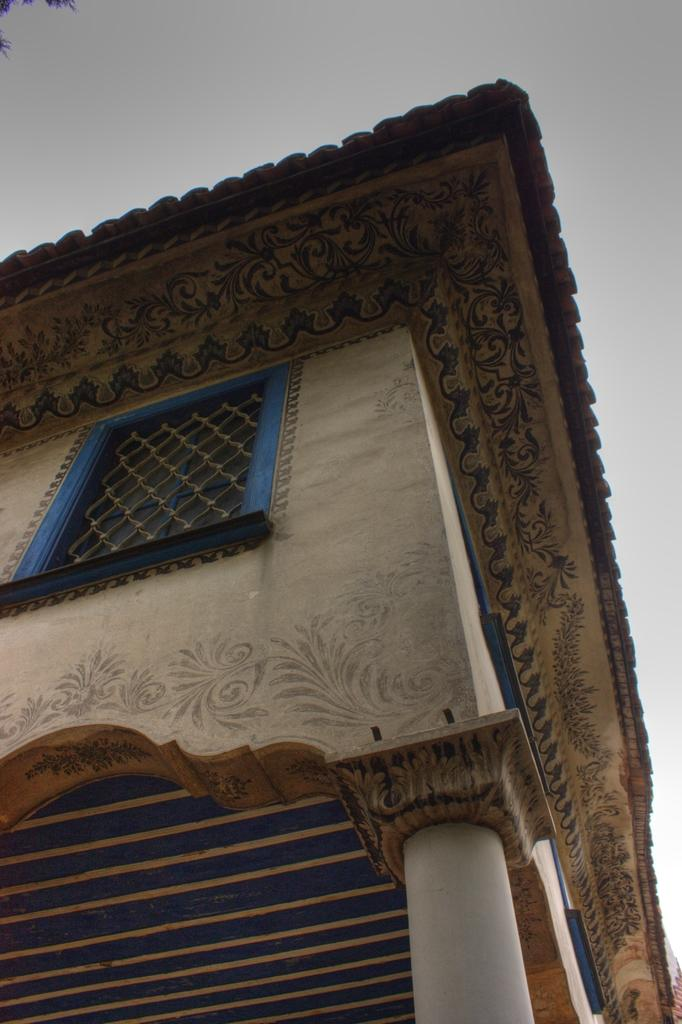Where was the image taken? The image was clicked outside. What can be seen in the image besides the sky? There is a building in the image. What is visible at the top of the image? The sky is visible at the top of the image. How many feathers can be seen floating in the sky in the image? There are no feathers visible in the image; only the sky and a building are present. 